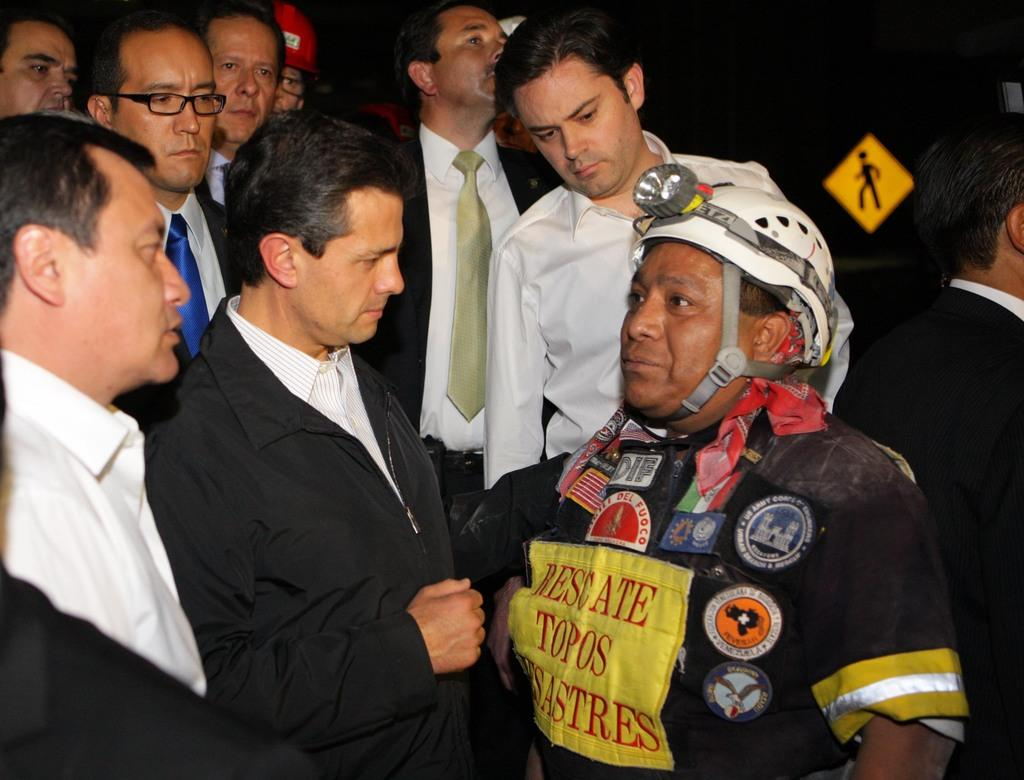What can be seen in the image involving a group of people? There is a group of people in the image. What object is present in the image that provides information or direction? There is a signboard in the image. What type of decorative items are visible in the image? There are stickers in the image. What type of clothing is worn by some people in the group? Some people in the group are wearing blazers, ties, and helmets. How would you describe the lighting in the image? The background of the image is dark. What type of screw can be seen holding the signboard in the image? There is no screw visible in the image holding the signboard; it is not mentioned in the provided facts. 